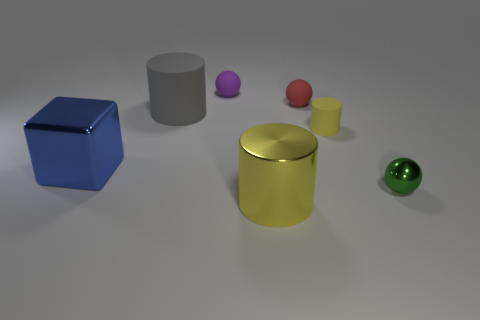What are the colors of the objects present on the table from left to right? From left to right, the objects' colors are blue, gray, purple, pink, red, yellow, and green. 